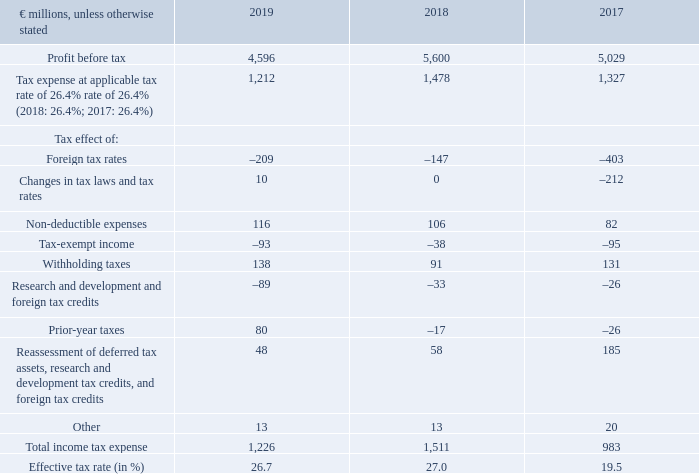The following table reconciles the expected income tax expense, computed by applying our combined German tax rate of 26.4% (2018: 26.4%; 2017: 26.4%), to the actual income tax expense. Our 2019 combined German tax rate includes a corporate income tax rate of 15.0% (2018: 15.0%; 2017: 15.0%), plus a solidarity surcharge of 5.5% (2018: 5.5%; 2017: 5.5%) thereon, and trade taxes of 10.6% (2018: 10.6%; 2017: 10.6%).
Relationship Between Tax Expense and Profit Before Tax
What was the profit before tax in 2019?
Answer scale should be: million. 4,596. In which years was the Relationship Between Tax Expense and Profit Before Tax analyzed? 2019, 2018, 2017. What was the applicable tax rate in 2018? 26.4%. In which year was profit before tax the largest? 5,600>5,029>4,596
Answer: 2018. What was the change in Other in 2019 from 2018?
Answer scale should be: million. 13-13
Answer: 0. What was the percentage change in Other in 2019 from 2018?
Answer scale should be: percent. (13-13)/13
Answer: 0. 